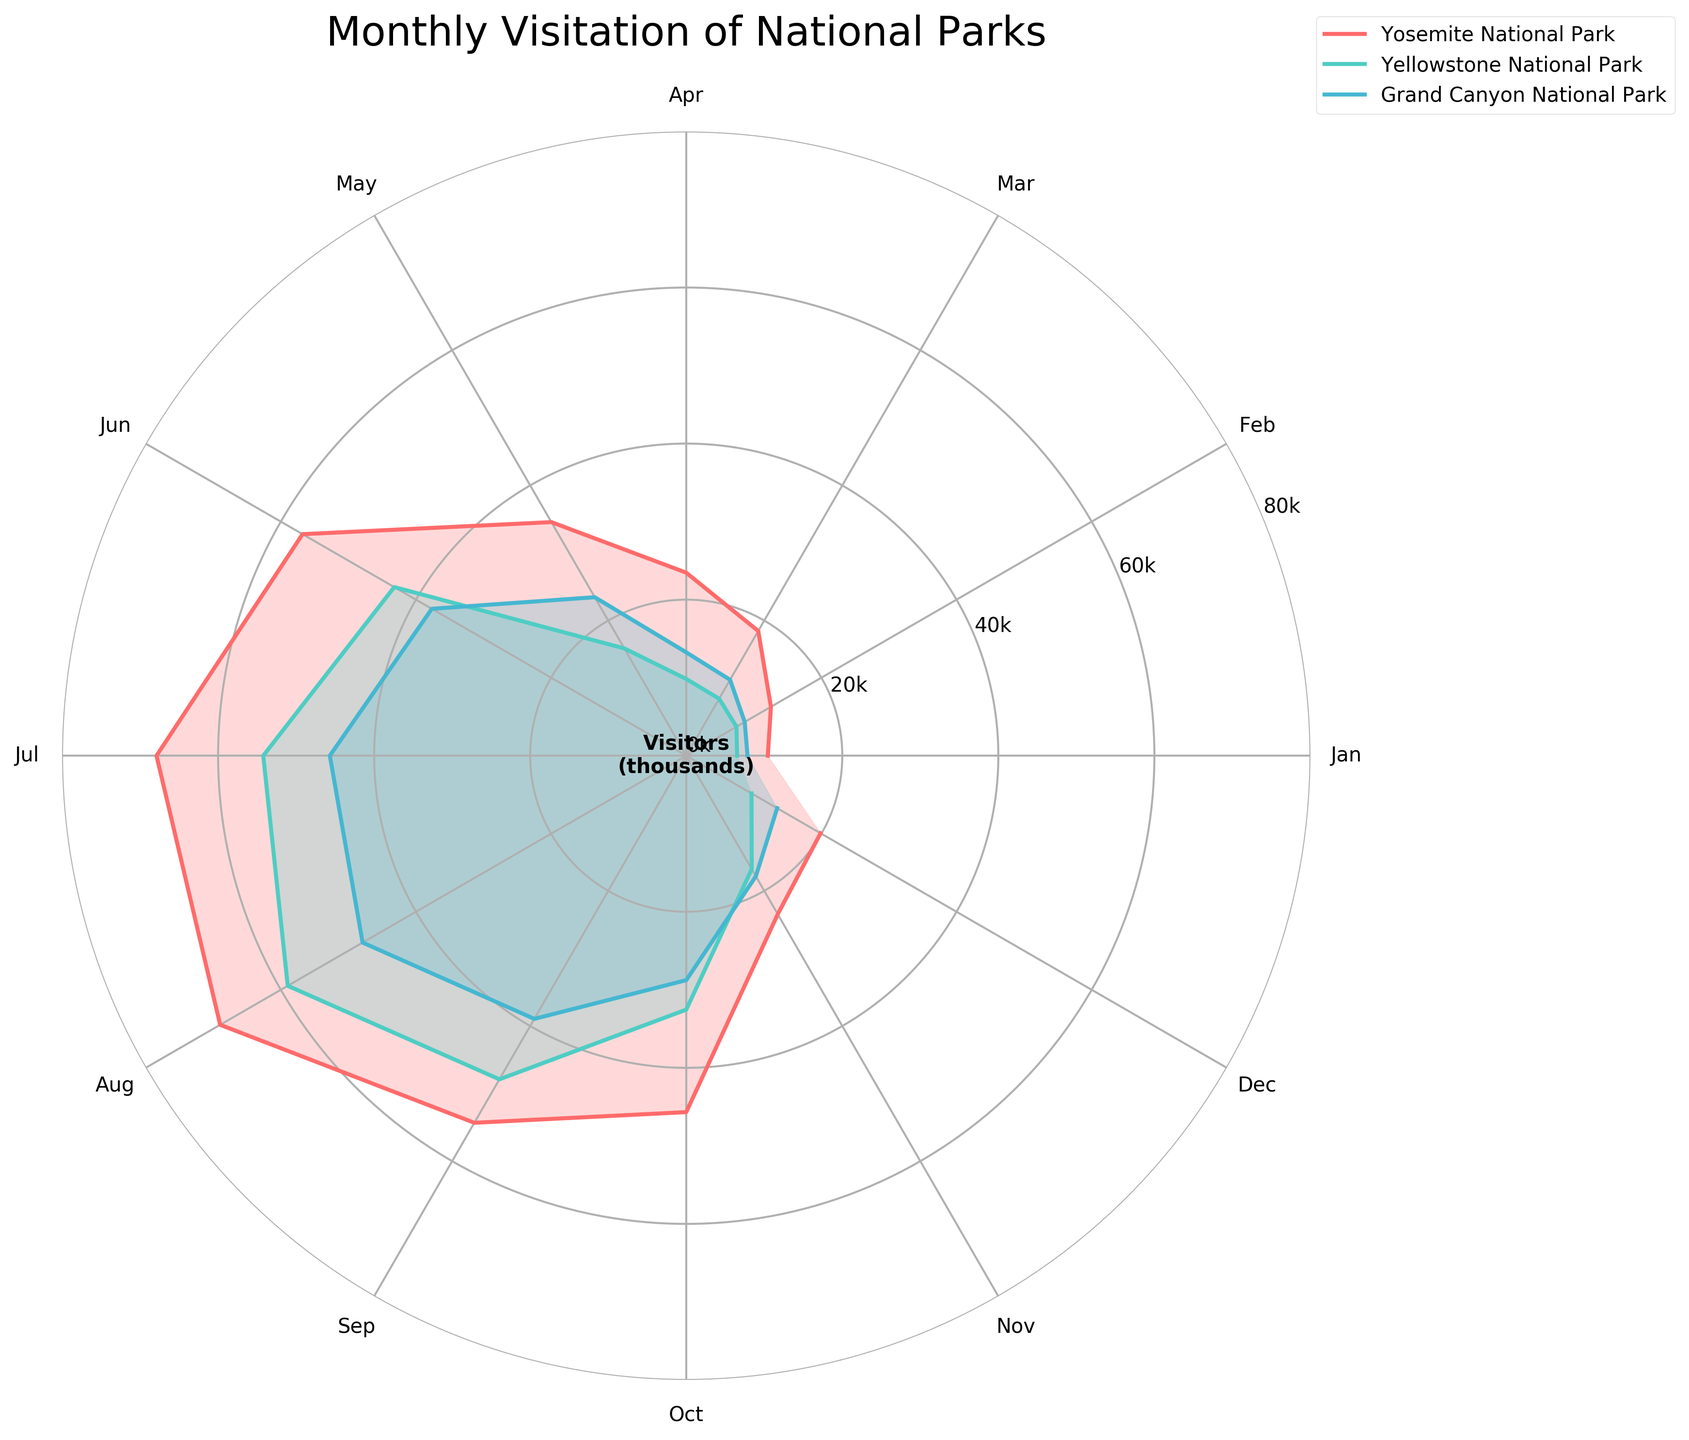Which national park has the highest visitor count in July? Look at the radial line for July on the rose chart and compare the lengths corresponding to each park. Find the longest one.
Answer: Yosemite National Park What is the difference in visitor counts between the highest and lowest months for Yosemite National Park? Find the length of the radial lines for the highest and lowest months for Yosemite National Park. The highest is July with ~67.9k visitors, and the lowest is January with ~10.4k visitors. Subtract the smallest value from the largest value.
Answer: 57,438 visitors Which month saw the fewest visitors for Yellowstone National Park? Identify the shortest radial line corresponding to Yellowstone National Park. The shortest segment is January with ~6.5k visitors.
Answer: January Compare the visitor counts of August for all three national parks. Which park had the highest count? Check the radial lines for August for each national park and compare their lengths. The longest radial line for August corresponds to Yosemite National Park.
Answer: Yosemite National Park In which month did the Grand Canyon National Park see a visitor count closest to 20k? Examine the radial lines for the Grand Canyon National Park and find the one closest to 20k. The closest month is May with approximately 23.5k visitors.
Answer: May What is the average number of visitors for Yosemite National Park in the first three months of the year? Sum the visitor counts for January, February, and March, which are ~10.4k, ~12.5k, and ~18.5k, respectively. Divide the sum by 3 to get the average.
Answer: 14,482 visitors How do the visitation patterns of Grand Canyon National Park in June compare to September? Compare the radial lengths for Grand Canyon National Park in June and September. June has a longer radial line (~37.6k visitors) compared to September (~38.9k visitors).
Answer: September has higher visitors than June What is the cumulative visitor count for Yosemite National Park in the summer months (June-August)? Add the visitor counts for June, July, and August for Yosemite National Park, which are ~56.8k, ~67.9k, and ~68.9k, respectively.
Answer: 192,654 visitors 